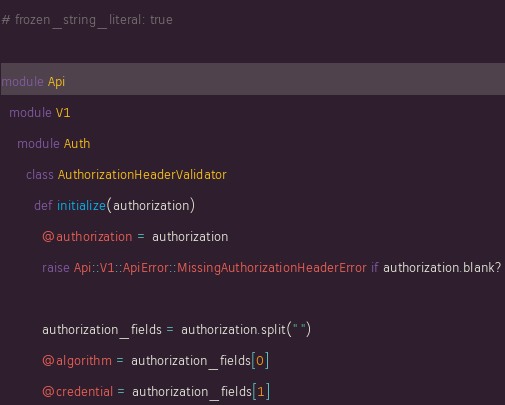Convert code to text. <code><loc_0><loc_0><loc_500><loc_500><_Ruby_># frozen_string_literal: true

module Api
  module V1
    module Auth
      class AuthorizationHeaderValidator
        def initialize(authorization)
          @authorization = authorization
          raise Api::V1::ApiError::MissingAuthorizationHeaderError if authorization.blank?

          authorization_fields = authorization.split(" ")
          @algorithm = authorization_fields[0]
          @credential = authorization_fields[1]</code> 